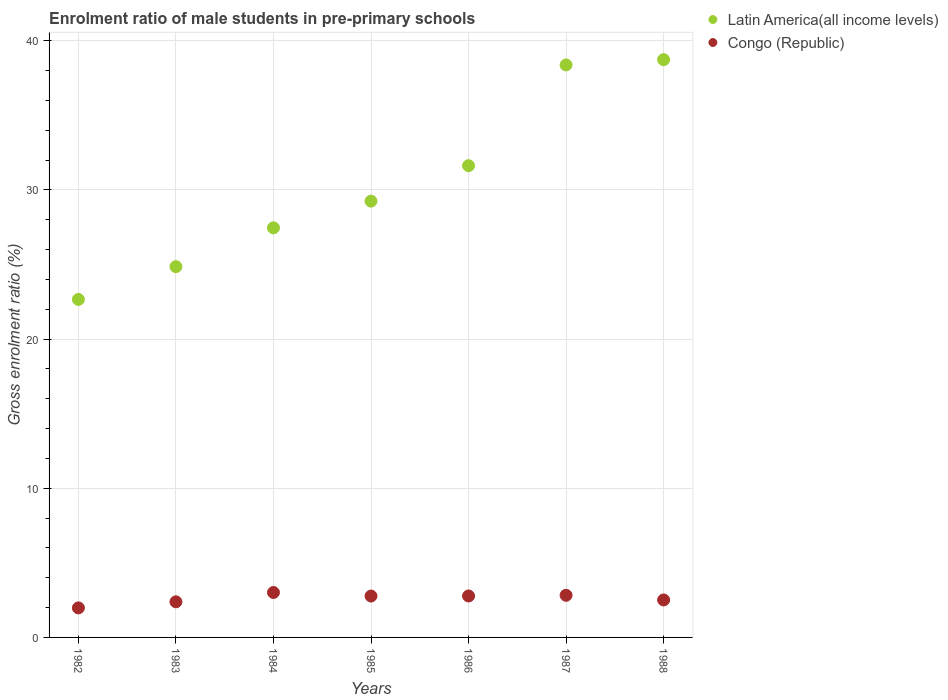How many different coloured dotlines are there?
Make the answer very short. 2. Is the number of dotlines equal to the number of legend labels?
Your answer should be very brief. Yes. What is the enrolment ratio of male students in pre-primary schools in Congo (Republic) in 1986?
Your response must be concise. 2.78. Across all years, what is the maximum enrolment ratio of male students in pre-primary schools in Latin America(all income levels)?
Ensure brevity in your answer.  38.74. Across all years, what is the minimum enrolment ratio of male students in pre-primary schools in Congo (Republic)?
Provide a short and direct response. 1.98. In which year was the enrolment ratio of male students in pre-primary schools in Latin America(all income levels) minimum?
Your answer should be very brief. 1982. What is the total enrolment ratio of male students in pre-primary schools in Latin America(all income levels) in the graph?
Give a very brief answer. 212.98. What is the difference between the enrolment ratio of male students in pre-primary schools in Latin America(all income levels) in 1982 and that in 1983?
Provide a succinct answer. -2.2. What is the difference between the enrolment ratio of male students in pre-primary schools in Congo (Republic) in 1985 and the enrolment ratio of male students in pre-primary schools in Latin America(all income levels) in 1987?
Keep it short and to the point. -35.61. What is the average enrolment ratio of male students in pre-primary schools in Congo (Republic) per year?
Provide a short and direct response. 2.61. In the year 1983, what is the difference between the enrolment ratio of male students in pre-primary schools in Latin America(all income levels) and enrolment ratio of male students in pre-primary schools in Congo (Republic)?
Your answer should be compact. 22.47. In how many years, is the enrolment ratio of male students in pre-primary schools in Congo (Republic) greater than 38 %?
Keep it short and to the point. 0. What is the ratio of the enrolment ratio of male students in pre-primary schools in Latin America(all income levels) in 1982 to that in 1986?
Make the answer very short. 0.72. Is the enrolment ratio of male students in pre-primary schools in Congo (Republic) in 1983 less than that in 1986?
Your answer should be compact. Yes. Is the difference between the enrolment ratio of male students in pre-primary schools in Latin America(all income levels) in 1984 and 1985 greater than the difference between the enrolment ratio of male students in pre-primary schools in Congo (Republic) in 1984 and 1985?
Provide a short and direct response. No. What is the difference between the highest and the second highest enrolment ratio of male students in pre-primary schools in Latin America(all income levels)?
Make the answer very short. 0.35. What is the difference between the highest and the lowest enrolment ratio of male students in pre-primary schools in Latin America(all income levels)?
Your answer should be very brief. 16.08. In how many years, is the enrolment ratio of male students in pre-primary schools in Latin America(all income levels) greater than the average enrolment ratio of male students in pre-primary schools in Latin America(all income levels) taken over all years?
Give a very brief answer. 3. Is the enrolment ratio of male students in pre-primary schools in Congo (Republic) strictly greater than the enrolment ratio of male students in pre-primary schools in Latin America(all income levels) over the years?
Your answer should be compact. No. Is the enrolment ratio of male students in pre-primary schools in Congo (Republic) strictly less than the enrolment ratio of male students in pre-primary schools in Latin America(all income levels) over the years?
Provide a short and direct response. Yes. How many dotlines are there?
Keep it short and to the point. 2. Does the graph contain grids?
Give a very brief answer. Yes. How many legend labels are there?
Your answer should be very brief. 2. What is the title of the graph?
Give a very brief answer. Enrolment ratio of male students in pre-primary schools. Does "Macao" appear as one of the legend labels in the graph?
Your answer should be compact. No. What is the label or title of the X-axis?
Offer a terse response. Years. What is the Gross enrolment ratio (%) of Latin America(all income levels) in 1982?
Make the answer very short. 22.66. What is the Gross enrolment ratio (%) of Congo (Republic) in 1982?
Provide a short and direct response. 1.98. What is the Gross enrolment ratio (%) in Latin America(all income levels) in 1983?
Your answer should be compact. 24.86. What is the Gross enrolment ratio (%) in Congo (Republic) in 1983?
Provide a succinct answer. 2.39. What is the Gross enrolment ratio (%) in Latin America(all income levels) in 1984?
Your response must be concise. 27.46. What is the Gross enrolment ratio (%) in Congo (Republic) in 1984?
Keep it short and to the point. 3.01. What is the Gross enrolment ratio (%) of Latin America(all income levels) in 1985?
Offer a very short reply. 29.25. What is the Gross enrolment ratio (%) of Congo (Republic) in 1985?
Keep it short and to the point. 2.78. What is the Gross enrolment ratio (%) in Latin America(all income levels) in 1986?
Keep it short and to the point. 31.63. What is the Gross enrolment ratio (%) in Congo (Republic) in 1986?
Provide a short and direct response. 2.78. What is the Gross enrolment ratio (%) in Latin America(all income levels) in 1987?
Give a very brief answer. 38.38. What is the Gross enrolment ratio (%) in Congo (Republic) in 1987?
Offer a terse response. 2.83. What is the Gross enrolment ratio (%) of Latin America(all income levels) in 1988?
Make the answer very short. 38.74. What is the Gross enrolment ratio (%) in Congo (Republic) in 1988?
Make the answer very short. 2.51. Across all years, what is the maximum Gross enrolment ratio (%) of Latin America(all income levels)?
Make the answer very short. 38.74. Across all years, what is the maximum Gross enrolment ratio (%) in Congo (Republic)?
Your answer should be very brief. 3.01. Across all years, what is the minimum Gross enrolment ratio (%) in Latin America(all income levels)?
Give a very brief answer. 22.66. Across all years, what is the minimum Gross enrolment ratio (%) in Congo (Republic)?
Make the answer very short. 1.98. What is the total Gross enrolment ratio (%) of Latin America(all income levels) in the graph?
Keep it short and to the point. 212.98. What is the total Gross enrolment ratio (%) in Congo (Republic) in the graph?
Your answer should be compact. 18.27. What is the difference between the Gross enrolment ratio (%) of Latin America(all income levels) in 1982 and that in 1983?
Provide a succinct answer. -2.2. What is the difference between the Gross enrolment ratio (%) of Congo (Republic) in 1982 and that in 1983?
Provide a short and direct response. -0.41. What is the difference between the Gross enrolment ratio (%) of Latin America(all income levels) in 1982 and that in 1984?
Offer a very short reply. -4.8. What is the difference between the Gross enrolment ratio (%) in Congo (Republic) in 1982 and that in 1984?
Provide a short and direct response. -1.03. What is the difference between the Gross enrolment ratio (%) of Latin America(all income levels) in 1982 and that in 1985?
Your response must be concise. -6.59. What is the difference between the Gross enrolment ratio (%) of Congo (Republic) in 1982 and that in 1985?
Give a very brief answer. -0.8. What is the difference between the Gross enrolment ratio (%) of Latin America(all income levels) in 1982 and that in 1986?
Your answer should be very brief. -8.97. What is the difference between the Gross enrolment ratio (%) of Congo (Republic) in 1982 and that in 1986?
Your response must be concise. -0.8. What is the difference between the Gross enrolment ratio (%) in Latin America(all income levels) in 1982 and that in 1987?
Keep it short and to the point. -15.72. What is the difference between the Gross enrolment ratio (%) of Congo (Republic) in 1982 and that in 1987?
Ensure brevity in your answer.  -0.85. What is the difference between the Gross enrolment ratio (%) of Latin America(all income levels) in 1982 and that in 1988?
Offer a terse response. -16.07. What is the difference between the Gross enrolment ratio (%) in Congo (Republic) in 1982 and that in 1988?
Keep it short and to the point. -0.53. What is the difference between the Gross enrolment ratio (%) of Latin America(all income levels) in 1983 and that in 1984?
Give a very brief answer. -2.6. What is the difference between the Gross enrolment ratio (%) in Congo (Republic) in 1983 and that in 1984?
Give a very brief answer. -0.63. What is the difference between the Gross enrolment ratio (%) in Latin America(all income levels) in 1983 and that in 1985?
Your answer should be very brief. -4.39. What is the difference between the Gross enrolment ratio (%) of Congo (Republic) in 1983 and that in 1985?
Make the answer very short. -0.39. What is the difference between the Gross enrolment ratio (%) of Latin America(all income levels) in 1983 and that in 1986?
Provide a short and direct response. -6.77. What is the difference between the Gross enrolment ratio (%) in Congo (Republic) in 1983 and that in 1986?
Provide a succinct answer. -0.39. What is the difference between the Gross enrolment ratio (%) of Latin America(all income levels) in 1983 and that in 1987?
Ensure brevity in your answer.  -13.52. What is the difference between the Gross enrolment ratio (%) in Congo (Republic) in 1983 and that in 1987?
Offer a terse response. -0.44. What is the difference between the Gross enrolment ratio (%) of Latin America(all income levels) in 1983 and that in 1988?
Provide a short and direct response. -13.88. What is the difference between the Gross enrolment ratio (%) of Congo (Republic) in 1983 and that in 1988?
Your answer should be very brief. -0.12. What is the difference between the Gross enrolment ratio (%) of Latin America(all income levels) in 1984 and that in 1985?
Ensure brevity in your answer.  -1.79. What is the difference between the Gross enrolment ratio (%) of Congo (Republic) in 1984 and that in 1985?
Your response must be concise. 0.24. What is the difference between the Gross enrolment ratio (%) in Latin America(all income levels) in 1984 and that in 1986?
Keep it short and to the point. -4.17. What is the difference between the Gross enrolment ratio (%) in Congo (Republic) in 1984 and that in 1986?
Give a very brief answer. 0.23. What is the difference between the Gross enrolment ratio (%) in Latin America(all income levels) in 1984 and that in 1987?
Ensure brevity in your answer.  -10.92. What is the difference between the Gross enrolment ratio (%) of Congo (Republic) in 1984 and that in 1987?
Your response must be concise. 0.19. What is the difference between the Gross enrolment ratio (%) in Latin America(all income levels) in 1984 and that in 1988?
Ensure brevity in your answer.  -11.28. What is the difference between the Gross enrolment ratio (%) of Congo (Republic) in 1984 and that in 1988?
Offer a terse response. 0.5. What is the difference between the Gross enrolment ratio (%) in Latin America(all income levels) in 1985 and that in 1986?
Your answer should be very brief. -2.38. What is the difference between the Gross enrolment ratio (%) of Congo (Republic) in 1985 and that in 1986?
Your response must be concise. -0. What is the difference between the Gross enrolment ratio (%) in Latin America(all income levels) in 1985 and that in 1987?
Ensure brevity in your answer.  -9.13. What is the difference between the Gross enrolment ratio (%) of Congo (Republic) in 1985 and that in 1987?
Provide a succinct answer. -0.05. What is the difference between the Gross enrolment ratio (%) in Latin America(all income levels) in 1985 and that in 1988?
Provide a succinct answer. -9.48. What is the difference between the Gross enrolment ratio (%) in Congo (Republic) in 1985 and that in 1988?
Give a very brief answer. 0.26. What is the difference between the Gross enrolment ratio (%) in Latin America(all income levels) in 1986 and that in 1987?
Keep it short and to the point. -6.75. What is the difference between the Gross enrolment ratio (%) in Congo (Republic) in 1986 and that in 1987?
Your response must be concise. -0.05. What is the difference between the Gross enrolment ratio (%) of Latin America(all income levels) in 1986 and that in 1988?
Keep it short and to the point. -7.11. What is the difference between the Gross enrolment ratio (%) in Congo (Republic) in 1986 and that in 1988?
Keep it short and to the point. 0.27. What is the difference between the Gross enrolment ratio (%) in Latin America(all income levels) in 1987 and that in 1988?
Your response must be concise. -0.35. What is the difference between the Gross enrolment ratio (%) in Congo (Republic) in 1987 and that in 1988?
Provide a succinct answer. 0.31. What is the difference between the Gross enrolment ratio (%) in Latin America(all income levels) in 1982 and the Gross enrolment ratio (%) in Congo (Republic) in 1983?
Your answer should be compact. 20.27. What is the difference between the Gross enrolment ratio (%) of Latin America(all income levels) in 1982 and the Gross enrolment ratio (%) of Congo (Republic) in 1984?
Ensure brevity in your answer.  19.65. What is the difference between the Gross enrolment ratio (%) of Latin America(all income levels) in 1982 and the Gross enrolment ratio (%) of Congo (Republic) in 1985?
Your answer should be compact. 19.89. What is the difference between the Gross enrolment ratio (%) in Latin America(all income levels) in 1982 and the Gross enrolment ratio (%) in Congo (Republic) in 1986?
Your response must be concise. 19.88. What is the difference between the Gross enrolment ratio (%) of Latin America(all income levels) in 1982 and the Gross enrolment ratio (%) of Congo (Republic) in 1987?
Your answer should be compact. 19.84. What is the difference between the Gross enrolment ratio (%) of Latin America(all income levels) in 1982 and the Gross enrolment ratio (%) of Congo (Republic) in 1988?
Keep it short and to the point. 20.15. What is the difference between the Gross enrolment ratio (%) of Latin America(all income levels) in 1983 and the Gross enrolment ratio (%) of Congo (Republic) in 1984?
Keep it short and to the point. 21.84. What is the difference between the Gross enrolment ratio (%) of Latin America(all income levels) in 1983 and the Gross enrolment ratio (%) of Congo (Republic) in 1985?
Give a very brief answer. 22.08. What is the difference between the Gross enrolment ratio (%) of Latin America(all income levels) in 1983 and the Gross enrolment ratio (%) of Congo (Republic) in 1986?
Offer a terse response. 22.08. What is the difference between the Gross enrolment ratio (%) in Latin America(all income levels) in 1983 and the Gross enrolment ratio (%) in Congo (Republic) in 1987?
Your answer should be compact. 22.03. What is the difference between the Gross enrolment ratio (%) in Latin America(all income levels) in 1983 and the Gross enrolment ratio (%) in Congo (Republic) in 1988?
Offer a terse response. 22.35. What is the difference between the Gross enrolment ratio (%) of Latin America(all income levels) in 1984 and the Gross enrolment ratio (%) of Congo (Republic) in 1985?
Ensure brevity in your answer.  24.69. What is the difference between the Gross enrolment ratio (%) of Latin America(all income levels) in 1984 and the Gross enrolment ratio (%) of Congo (Republic) in 1986?
Make the answer very short. 24.68. What is the difference between the Gross enrolment ratio (%) of Latin America(all income levels) in 1984 and the Gross enrolment ratio (%) of Congo (Republic) in 1987?
Your answer should be very brief. 24.64. What is the difference between the Gross enrolment ratio (%) of Latin America(all income levels) in 1984 and the Gross enrolment ratio (%) of Congo (Republic) in 1988?
Offer a terse response. 24.95. What is the difference between the Gross enrolment ratio (%) of Latin America(all income levels) in 1985 and the Gross enrolment ratio (%) of Congo (Republic) in 1986?
Keep it short and to the point. 26.47. What is the difference between the Gross enrolment ratio (%) in Latin America(all income levels) in 1985 and the Gross enrolment ratio (%) in Congo (Republic) in 1987?
Give a very brief answer. 26.43. What is the difference between the Gross enrolment ratio (%) of Latin America(all income levels) in 1985 and the Gross enrolment ratio (%) of Congo (Republic) in 1988?
Offer a terse response. 26.74. What is the difference between the Gross enrolment ratio (%) of Latin America(all income levels) in 1986 and the Gross enrolment ratio (%) of Congo (Republic) in 1987?
Give a very brief answer. 28.8. What is the difference between the Gross enrolment ratio (%) in Latin America(all income levels) in 1986 and the Gross enrolment ratio (%) in Congo (Republic) in 1988?
Your response must be concise. 29.12. What is the difference between the Gross enrolment ratio (%) in Latin America(all income levels) in 1987 and the Gross enrolment ratio (%) in Congo (Republic) in 1988?
Your response must be concise. 35.87. What is the average Gross enrolment ratio (%) in Latin America(all income levels) per year?
Provide a succinct answer. 30.43. What is the average Gross enrolment ratio (%) in Congo (Republic) per year?
Make the answer very short. 2.61. In the year 1982, what is the difference between the Gross enrolment ratio (%) of Latin America(all income levels) and Gross enrolment ratio (%) of Congo (Republic)?
Your answer should be very brief. 20.68. In the year 1983, what is the difference between the Gross enrolment ratio (%) in Latin America(all income levels) and Gross enrolment ratio (%) in Congo (Republic)?
Your answer should be compact. 22.47. In the year 1984, what is the difference between the Gross enrolment ratio (%) of Latin America(all income levels) and Gross enrolment ratio (%) of Congo (Republic)?
Your response must be concise. 24.45. In the year 1985, what is the difference between the Gross enrolment ratio (%) in Latin America(all income levels) and Gross enrolment ratio (%) in Congo (Republic)?
Keep it short and to the point. 26.48. In the year 1986, what is the difference between the Gross enrolment ratio (%) in Latin America(all income levels) and Gross enrolment ratio (%) in Congo (Republic)?
Give a very brief answer. 28.85. In the year 1987, what is the difference between the Gross enrolment ratio (%) of Latin America(all income levels) and Gross enrolment ratio (%) of Congo (Republic)?
Offer a very short reply. 35.56. In the year 1988, what is the difference between the Gross enrolment ratio (%) in Latin America(all income levels) and Gross enrolment ratio (%) in Congo (Republic)?
Provide a short and direct response. 36.22. What is the ratio of the Gross enrolment ratio (%) in Latin America(all income levels) in 1982 to that in 1983?
Offer a very short reply. 0.91. What is the ratio of the Gross enrolment ratio (%) in Congo (Republic) in 1982 to that in 1983?
Make the answer very short. 0.83. What is the ratio of the Gross enrolment ratio (%) of Latin America(all income levels) in 1982 to that in 1984?
Make the answer very short. 0.83. What is the ratio of the Gross enrolment ratio (%) of Congo (Republic) in 1982 to that in 1984?
Ensure brevity in your answer.  0.66. What is the ratio of the Gross enrolment ratio (%) of Latin America(all income levels) in 1982 to that in 1985?
Provide a short and direct response. 0.77. What is the ratio of the Gross enrolment ratio (%) in Congo (Republic) in 1982 to that in 1985?
Make the answer very short. 0.71. What is the ratio of the Gross enrolment ratio (%) of Latin America(all income levels) in 1982 to that in 1986?
Give a very brief answer. 0.72. What is the ratio of the Gross enrolment ratio (%) of Congo (Republic) in 1982 to that in 1986?
Give a very brief answer. 0.71. What is the ratio of the Gross enrolment ratio (%) of Latin America(all income levels) in 1982 to that in 1987?
Your answer should be very brief. 0.59. What is the ratio of the Gross enrolment ratio (%) of Congo (Republic) in 1982 to that in 1987?
Your answer should be compact. 0.7. What is the ratio of the Gross enrolment ratio (%) in Latin America(all income levels) in 1982 to that in 1988?
Your answer should be very brief. 0.58. What is the ratio of the Gross enrolment ratio (%) in Congo (Republic) in 1982 to that in 1988?
Provide a short and direct response. 0.79. What is the ratio of the Gross enrolment ratio (%) of Latin America(all income levels) in 1983 to that in 1984?
Ensure brevity in your answer.  0.91. What is the ratio of the Gross enrolment ratio (%) of Congo (Republic) in 1983 to that in 1984?
Offer a terse response. 0.79. What is the ratio of the Gross enrolment ratio (%) in Latin America(all income levels) in 1983 to that in 1985?
Ensure brevity in your answer.  0.85. What is the ratio of the Gross enrolment ratio (%) of Congo (Republic) in 1983 to that in 1985?
Your response must be concise. 0.86. What is the ratio of the Gross enrolment ratio (%) in Latin America(all income levels) in 1983 to that in 1986?
Your answer should be very brief. 0.79. What is the ratio of the Gross enrolment ratio (%) in Congo (Republic) in 1983 to that in 1986?
Ensure brevity in your answer.  0.86. What is the ratio of the Gross enrolment ratio (%) of Latin America(all income levels) in 1983 to that in 1987?
Your answer should be very brief. 0.65. What is the ratio of the Gross enrolment ratio (%) of Congo (Republic) in 1983 to that in 1987?
Ensure brevity in your answer.  0.85. What is the ratio of the Gross enrolment ratio (%) in Latin America(all income levels) in 1983 to that in 1988?
Offer a very short reply. 0.64. What is the ratio of the Gross enrolment ratio (%) in Congo (Republic) in 1983 to that in 1988?
Your answer should be compact. 0.95. What is the ratio of the Gross enrolment ratio (%) in Latin America(all income levels) in 1984 to that in 1985?
Offer a terse response. 0.94. What is the ratio of the Gross enrolment ratio (%) in Congo (Republic) in 1984 to that in 1985?
Your response must be concise. 1.09. What is the ratio of the Gross enrolment ratio (%) in Latin America(all income levels) in 1984 to that in 1986?
Offer a terse response. 0.87. What is the ratio of the Gross enrolment ratio (%) in Congo (Republic) in 1984 to that in 1986?
Your answer should be compact. 1.08. What is the ratio of the Gross enrolment ratio (%) in Latin America(all income levels) in 1984 to that in 1987?
Your response must be concise. 0.72. What is the ratio of the Gross enrolment ratio (%) of Congo (Republic) in 1984 to that in 1987?
Your answer should be compact. 1.07. What is the ratio of the Gross enrolment ratio (%) of Latin America(all income levels) in 1984 to that in 1988?
Ensure brevity in your answer.  0.71. What is the ratio of the Gross enrolment ratio (%) of Congo (Republic) in 1984 to that in 1988?
Your response must be concise. 1.2. What is the ratio of the Gross enrolment ratio (%) in Latin America(all income levels) in 1985 to that in 1986?
Your response must be concise. 0.92. What is the ratio of the Gross enrolment ratio (%) of Latin America(all income levels) in 1985 to that in 1987?
Keep it short and to the point. 0.76. What is the ratio of the Gross enrolment ratio (%) of Congo (Republic) in 1985 to that in 1987?
Your answer should be compact. 0.98. What is the ratio of the Gross enrolment ratio (%) in Latin America(all income levels) in 1985 to that in 1988?
Keep it short and to the point. 0.76. What is the ratio of the Gross enrolment ratio (%) in Congo (Republic) in 1985 to that in 1988?
Your response must be concise. 1.1. What is the ratio of the Gross enrolment ratio (%) in Latin America(all income levels) in 1986 to that in 1987?
Keep it short and to the point. 0.82. What is the ratio of the Gross enrolment ratio (%) in Congo (Republic) in 1986 to that in 1987?
Offer a terse response. 0.98. What is the ratio of the Gross enrolment ratio (%) of Latin America(all income levels) in 1986 to that in 1988?
Make the answer very short. 0.82. What is the ratio of the Gross enrolment ratio (%) in Congo (Republic) in 1986 to that in 1988?
Give a very brief answer. 1.11. What is the ratio of the Gross enrolment ratio (%) of Latin America(all income levels) in 1987 to that in 1988?
Keep it short and to the point. 0.99. What is the ratio of the Gross enrolment ratio (%) of Congo (Republic) in 1987 to that in 1988?
Offer a very short reply. 1.12. What is the difference between the highest and the second highest Gross enrolment ratio (%) of Latin America(all income levels)?
Provide a succinct answer. 0.35. What is the difference between the highest and the second highest Gross enrolment ratio (%) of Congo (Republic)?
Your answer should be compact. 0.19. What is the difference between the highest and the lowest Gross enrolment ratio (%) of Latin America(all income levels)?
Keep it short and to the point. 16.07. What is the difference between the highest and the lowest Gross enrolment ratio (%) of Congo (Republic)?
Make the answer very short. 1.03. 